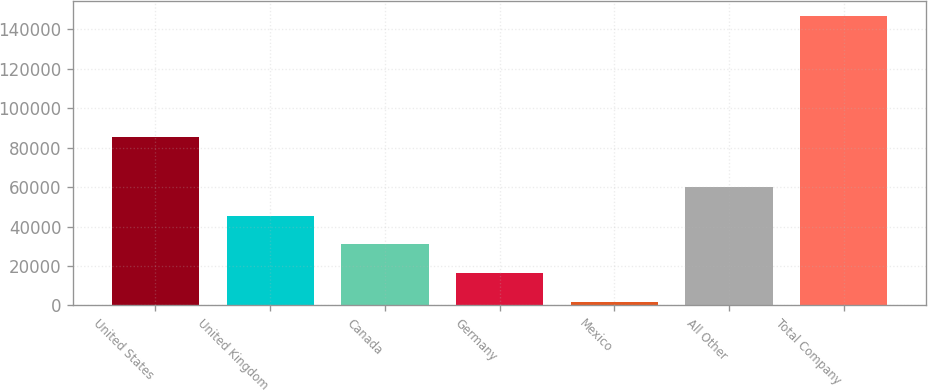<chart> <loc_0><loc_0><loc_500><loc_500><bar_chart><fcel>United States<fcel>United Kingdom<fcel>Canada<fcel>Germany<fcel>Mexico<fcel>All Other<fcel>Total Company<nl><fcel>85459<fcel>45469.5<fcel>30977<fcel>16484.5<fcel>1992<fcel>59962<fcel>146917<nl></chart> 